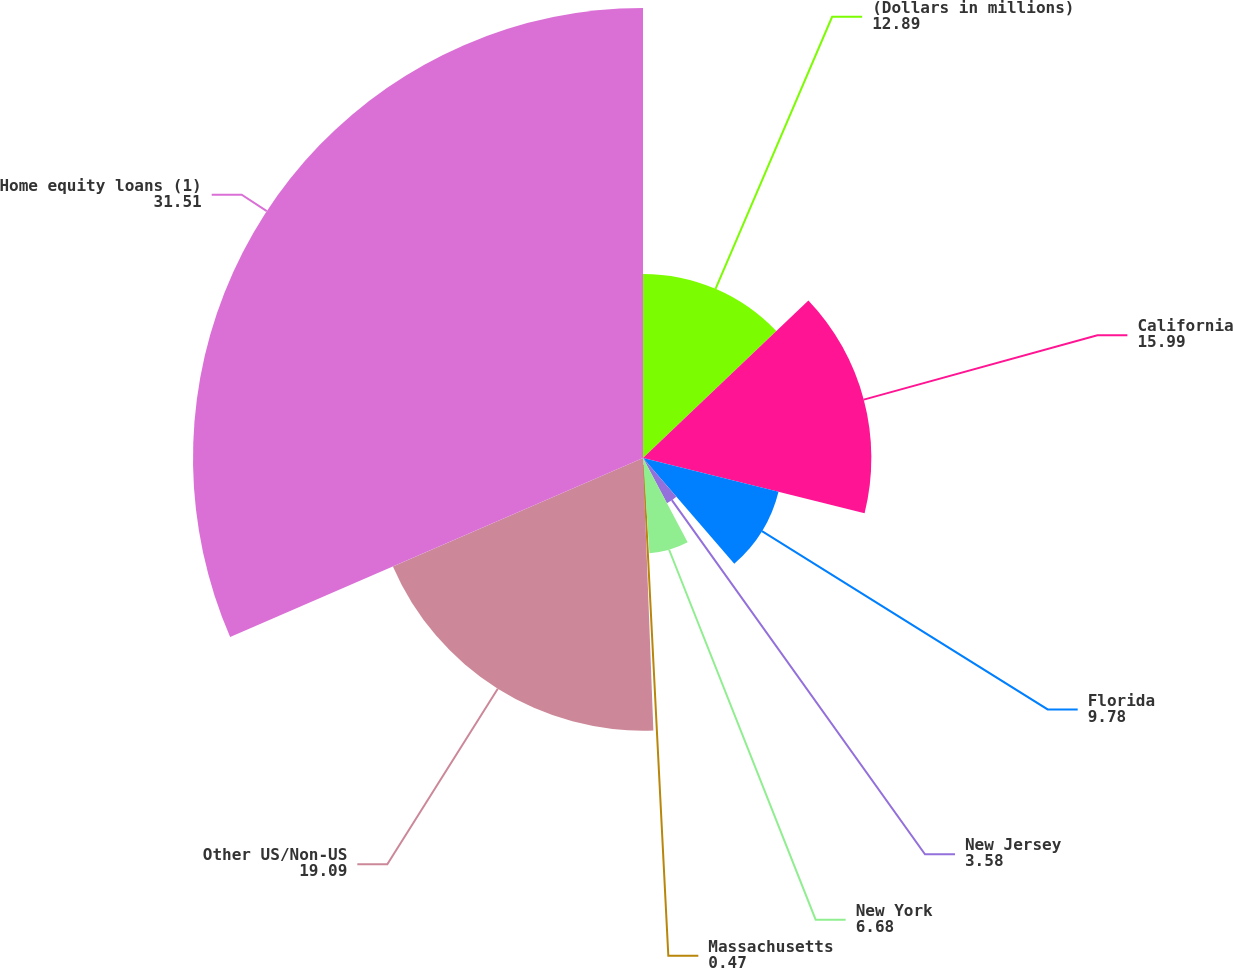Convert chart. <chart><loc_0><loc_0><loc_500><loc_500><pie_chart><fcel>(Dollars in millions)<fcel>California<fcel>Florida<fcel>New Jersey<fcel>New York<fcel>Massachusetts<fcel>Other US/Non-US<fcel>Home equity loans (1)<nl><fcel>12.89%<fcel>15.99%<fcel>9.78%<fcel>3.58%<fcel>6.68%<fcel>0.47%<fcel>19.09%<fcel>31.51%<nl></chart> 